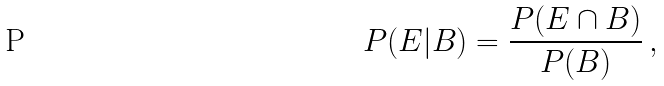Convert formula to latex. <formula><loc_0><loc_0><loc_500><loc_500>P ( E | B ) = \frac { P ( E \cap B ) } { P ( B ) } \, ,</formula> 